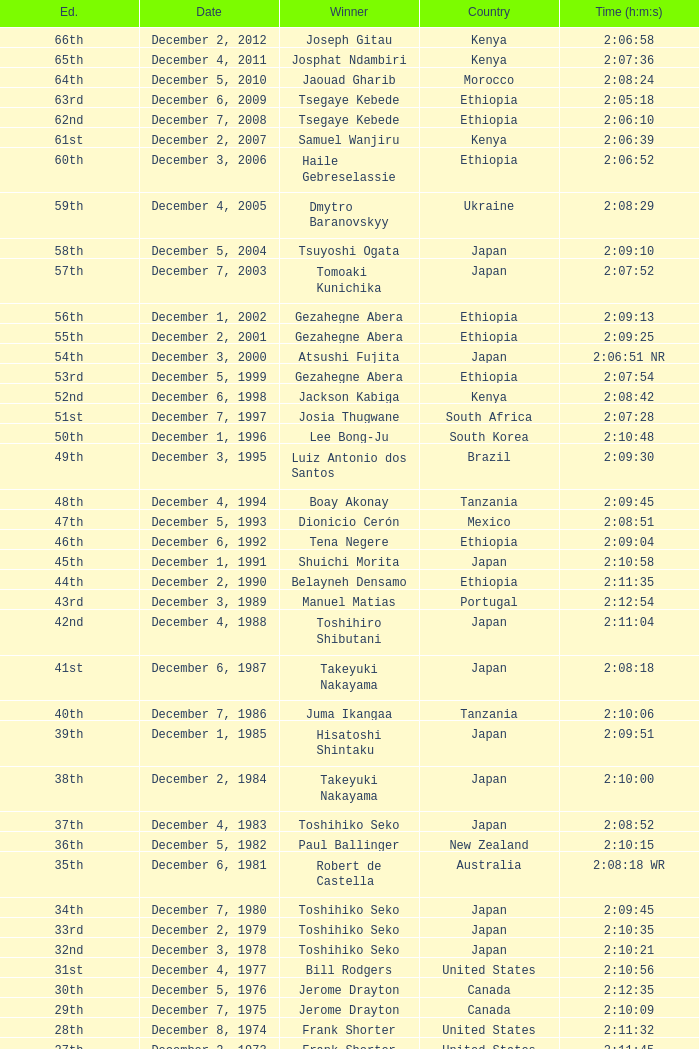On what date was the 48th Edition raced? December 4, 1994. 